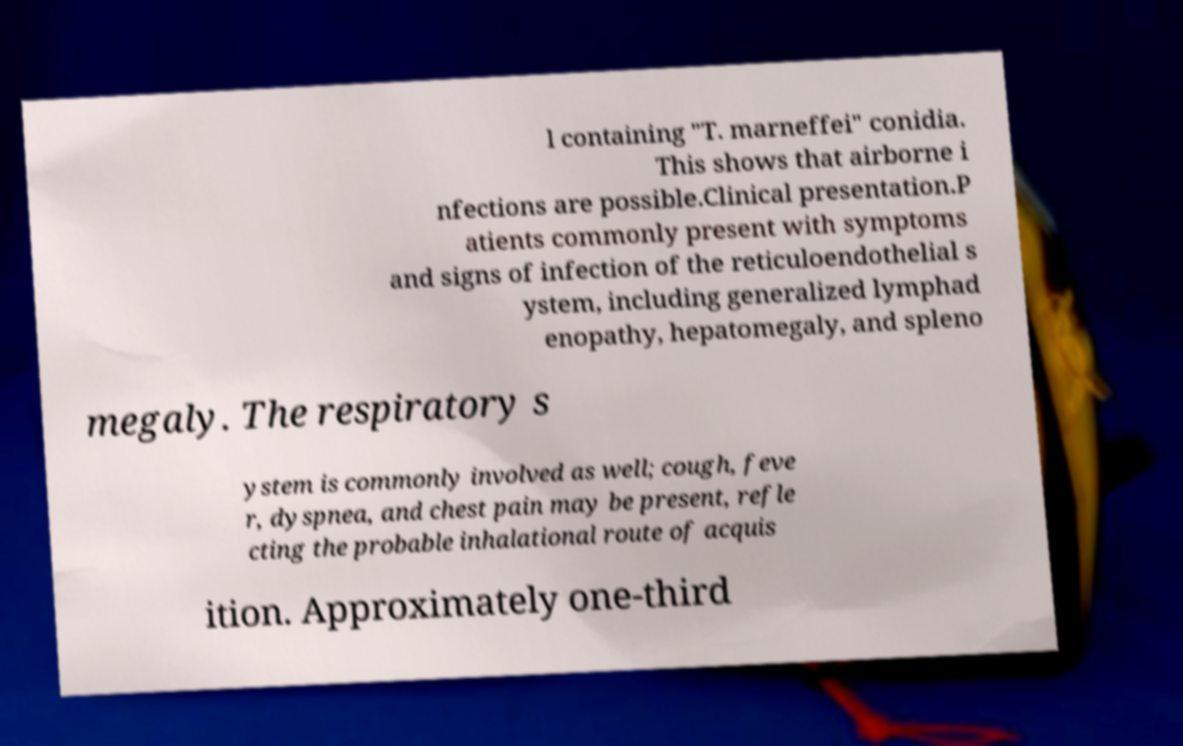What messages or text are displayed in this image? I need them in a readable, typed format. l containing "T. marneffei" conidia. This shows that airborne i nfections are possible.Clinical presentation.P atients commonly present with symptoms and signs of infection of the reticuloendothelial s ystem, including generalized lymphad enopathy, hepatomegaly, and spleno megaly. The respiratory s ystem is commonly involved as well; cough, feve r, dyspnea, and chest pain may be present, refle cting the probable inhalational route of acquis ition. Approximately one-third 